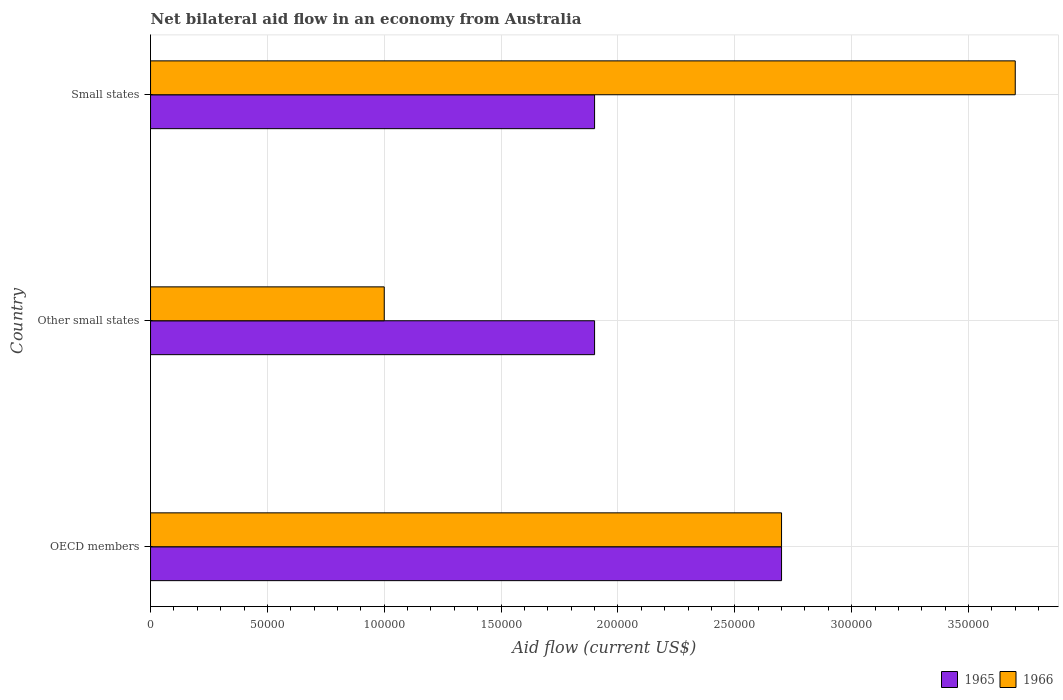How many different coloured bars are there?
Your answer should be very brief. 2. Are the number of bars on each tick of the Y-axis equal?
Offer a terse response. Yes. How many bars are there on the 3rd tick from the bottom?
Keep it short and to the point. 2. What is the label of the 1st group of bars from the top?
Your response must be concise. Small states. In how many cases, is the number of bars for a given country not equal to the number of legend labels?
Keep it short and to the point. 0. What is the net bilateral aid flow in 1965 in Small states?
Provide a succinct answer. 1.90e+05. Across all countries, what is the maximum net bilateral aid flow in 1966?
Make the answer very short. 3.70e+05. Across all countries, what is the minimum net bilateral aid flow in 1965?
Ensure brevity in your answer.  1.90e+05. In which country was the net bilateral aid flow in 1965 maximum?
Provide a succinct answer. OECD members. In which country was the net bilateral aid flow in 1966 minimum?
Keep it short and to the point. Other small states. What is the total net bilateral aid flow in 1965 in the graph?
Your answer should be very brief. 6.50e+05. What is the difference between the net bilateral aid flow in 1966 in Other small states and that in Small states?
Your answer should be very brief. -2.70e+05. What is the difference between the net bilateral aid flow in 1965 in OECD members and the net bilateral aid flow in 1966 in Small states?
Offer a terse response. -1.00e+05. What is the average net bilateral aid flow in 1965 per country?
Your response must be concise. 2.17e+05. In how many countries, is the net bilateral aid flow in 1965 greater than 260000 US$?
Keep it short and to the point. 1. What is the ratio of the net bilateral aid flow in 1966 in Other small states to that in Small states?
Keep it short and to the point. 0.27. Is the net bilateral aid flow in 1965 in OECD members less than that in Small states?
Your answer should be very brief. No. What is the difference between the highest and the second highest net bilateral aid flow in 1966?
Offer a very short reply. 1.00e+05. What is the difference between the highest and the lowest net bilateral aid flow in 1965?
Your response must be concise. 8.00e+04. In how many countries, is the net bilateral aid flow in 1966 greater than the average net bilateral aid flow in 1966 taken over all countries?
Provide a succinct answer. 2. What does the 2nd bar from the top in Other small states represents?
Offer a terse response. 1965. What does the 2nd bar from the bottom in OECD members represents?
Give a very brief answer. 1966. Are all the bars in the graph horizontal?
Provide a succinct answer. Yes. Are the values on the major ticks of X-axis written in scientific E-notation?
Offer a terse response. No. How many legend labels are there?
Give a very brief answer. 2. What is the title of the graph?
Provide a succinct answer. Net bilateral aid flow in an economy from Australia. Does "1972" appear as one of the legend labels in the graph?
Provide a short and direct response. No. What is the Aid flow (current US$) of 1965 in OECD members?
Ensure brevity in your answer.  2.70e+05. What is the Aid flow (current US$) of 1966 in OECD members?
Keep it short and to the point. 2.70e+05. What is the Aid flow (current US$) of 1965 in Other small states?
Your answer should be compact. 1.90e+05. What is the Aid flow (current US$) of 1966 in Other small states?
Keep it short and to the point. 1.00e+05. What is the Aid flow (current US$) in 1965 in Small states?
Your answer should be compact. 1.90e+05. Across all countries, what is the minimum Aid flow (current US$) of 1966?
Your answer should be very brief. 1.00e+05. What is the total Aid flow (current US$) in 1965 in the graph?
Your answer should be very brief. 6.50e+05. What is the total Aid flow (current US$) of 1966 in the graph?
Your response must be concise. 7.40e+05. What is the difference between the Aid flow (current US$) in 1965 in OECD members and that in Other small states?
Provide a short and direct response. 8.00e+04. What is the difference between the Aid flow (current US$) of 1965 in OECD members and that in Small states?
Your response must be concise. 8.00e+04. What is the difference between the Aid flow (current US$) of 1966 in OECD members and that in Small states?
Make the answer very short. -1.00e+05. What is the difference between the Aid flow (current US$) of 1965 in Other small states and that in Small states?
Keep it short and to the point. 0. What is the difference between the Aid flow (current US$) in 1966 in Other small states and that in Small states?
Provide a succinct answer. -2.70e+05. What is the difference between the Aid flow (current US$) of 1965 in OECD members and the Aid flow (current US$) of 1966 in Small states?
Your answer should be compact. -1.00e+05. What is the average Aid flow (current US$) of 1965 per country?
Provide a succinct answer. 2.17e+05. What is the average Aid flow (current US$) of 1966 per country?
Provide a short and direct response. 2.47e+05. What is the difference between the Aid flow (current US$) of 1965 and Aid flow (current US$) of 1966 in Small states?
Your response must be concise. -1.80e+05. What is the ratio of the Aid flow (current US$) of 1965 in OECD members to that in Other small states?
Provide a short and direct response. 1.42. What is the ratio of the Aid flow (current US$) of 1965 in OECD members to that in Small states?
Your answer should be very brief. 1.42. What is the ratio of the Aid flow (current US$) of 1966 in OECD members to that in Small states?
Provide a short and direct response. 0.73. What is the ratio of the Aid flow (current US$) of 1966 in Other small states to that in Small states?
Your answer should be compact. 0.27. What is the difference between the highest and the second highest Aid flow (current US$) of 1966?
Give a very brief answer. 1.00e+05. What is the difference between the highest and the lowest Aid flow (current US$) in 1965?
Offer a terse response. 8.00e+04. What is the difference between the highest and the lowest Aid flow (current US$) in 1966?
Keep it short and to the point. 2.70e+05. 